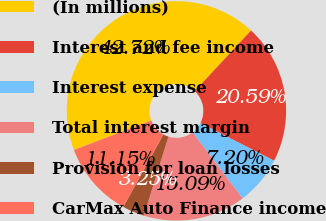<chart> <loc_0><loc_0><loc_500><loc_500><pie_chart><fcel>(In millions)<fcel>Interest and fee income<fcel>Interest expense<fcel>Total interest margin<fcel>Provision for loan losses<fcel>CarMax Auto Finance income<nl><fcel>42.72%<fcel>20.59%<fcel>7.2%<fcel>15.09%<fcel>3.25%<fcel>11.15%<nl></chart> 